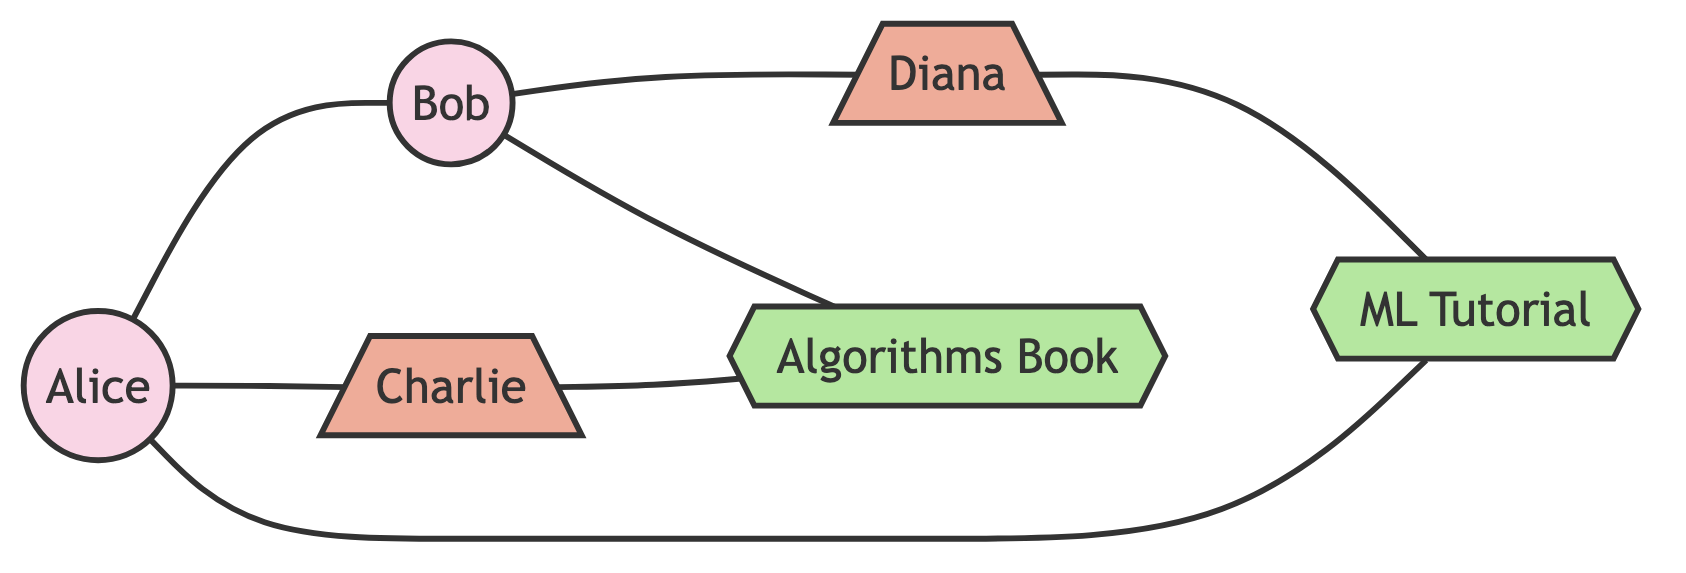What are the total number of nodes in the diagram? The diagram features a total of six nodes: two students, two educators, and two learning resources.
Answer: 6 Which educator is connected to Alice? The diagram shows a direct connection (edge) between Alice and educator Charlie.
Answer: Charlie How many learning resources are connected to Bob? Bob has one learning resource connected to him, which is the Algorithms Book.
Answer: 1 What is the connection between Diana and Bob? The diagram illustrates a direct edge between Bob and educator Diana, indicating they are connected.
Answer: Connected Which student is linked to the ML Tutorial resource? Students can be analyzed for their connections, and Alice is directly linked to the ML Tutorial resource.
Answer: Alice Who shares a connection with Charlie? After examining the edges in the diagram, it is clear that both Alice and educator Charlie share connections.
Answer: Alice How many edges are connecting the students in the diagram? By reviewing the edges, there are two connections specifically linking the students Alice and Bob.
Answer: 2 Is there any educator connected to the Algorithms Book? The diagram indicates that educator Charlie has a direct connection to the resource Algorithms Book, establishing a link.
Answer: Charlie Which learning resource is connected to Diana? On inspecting the diagram, it can be confirmed that the ML Tutorial resource is connected to educator Diana.
Answer: ML Tutorial 